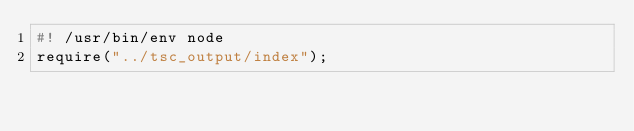<code> <loc_0><loc_0><loc_500><loc_500><_JavaScript_>#! /usr/bin/env node
require("../tsc_output/index");
</code> 